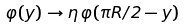<formula> <loc_0><loc_0><loc_500><loc_500>\varphi ( y ) \rightarrow \eta \, \varphi ( \pi R / 2 - y )</formula> 